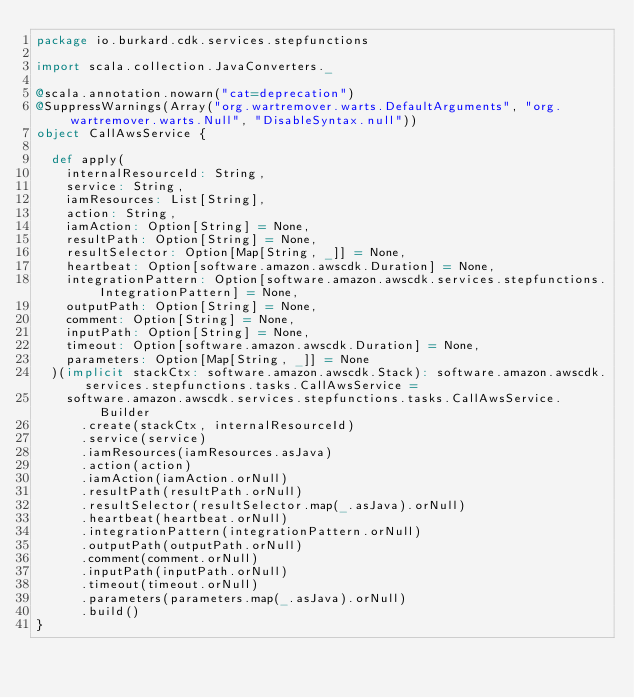Convert code to text. <code><loc_0><loc_0><loc_500><loc_500><_Scala_>package io.burkard.cdk.services.stepfunctions

import scala.collection.JavaConverters._

@scala.annotation.nowarn("cat=deprecation")
@SuppressWarnings(Array("org.wartremover.warts.DefaultArguments", "org.wartremover.warts.Null", "DisableSyntax.null"))
object CallAwsService {

  def apply(
    internalResourceId: String,
    service: String,
    iamResources: List[String],
    action: String,
    iamAction: Option[String] = None,
    resultPath: Option[String] = None,
    resultSelector: Option[Map[String, _]] = None,
    heartbeat: Option[software.amazon.awscdk.Duration] = None,
    integrationPattern: Option[software.amazon.awscdk.services.stepfunctions.IntegrationPattern] = None,
    outputPath: Option[String] = None,
    comment: Option[String] = None,
    inputPath: Option[String] = None,
    timeout: Option[software.amazon.awscdk.Duration] = None,
    parameters: Option[Map[String, _]] = None
  )(implicit stackCtx: software.amazon.awscdk.Stack): software.amazon.awscdk.services.stepfunctions.tasks.CallAwsService =
    software.amazon.awscdk.services.stepfunctions.tasks.CallAwsService.Builder
      .create(stackCtx, internalResourceId)
      .service(service)
      .iamResources(iamResources.asJava)
      .action(action)
      .iamAction(iamAction.orNull)
      .resultPath(resultPath.orNull)
      .resultSelector(resultSelector.map(_.asJava).orNull)
      .heartbeat(heartbeat.orNull)
      .integrationPattern(integrationPattern.orNull)
      .outputPath(outputPath.orNull)
      .comment(comment.orNull)
      .inputPath(inputPath.orNull)
      .timeout(timeout.orNull)
      .parameters(parameters.map(_.asJava).orNull)
      .build()
}
</code> 